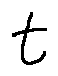<formula> <loc_0><loc_0><loc_500><loc_500>t</formula> 